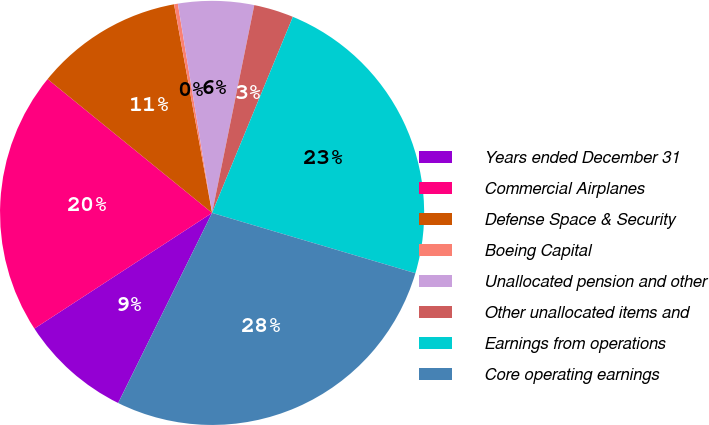Convert chart. <chart><loc_0><loc_0><loc_500><loc_500><pie_chart><fcel>Years ended December 31<fcel>Commercial Airplanes<fcel>Defense Space & Security<fcel>Boeing Capital<fcel>Unallocated pension and other<fcel>Other unallocated items and<fcel>Earnings from operations<fcel>Core operating earnings<nl><fcel>8.51%<fcel>20.05%<fcel>11.26%<fcel>0.29%<fcel>5.77%<fcel>3.03%<fcel>23.37%<fcel>27.71%<nl></chart> 